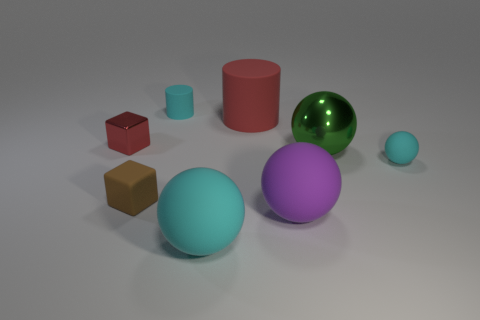Subtract 1 spheres. How many spheres are left? 3 Add 2 big shiny things. How many objects exist? 10 Subtract all cylinders. How many objects are left? 6 Add 3 balls. How many balls are left? 7 Add 4 metallic things. How many metallic things exist? 6 Subtract 0 blue blocks. How many objects are left? 8 Subtract all red objects. Subtract all rubber spheres. How many objects are left? 3 